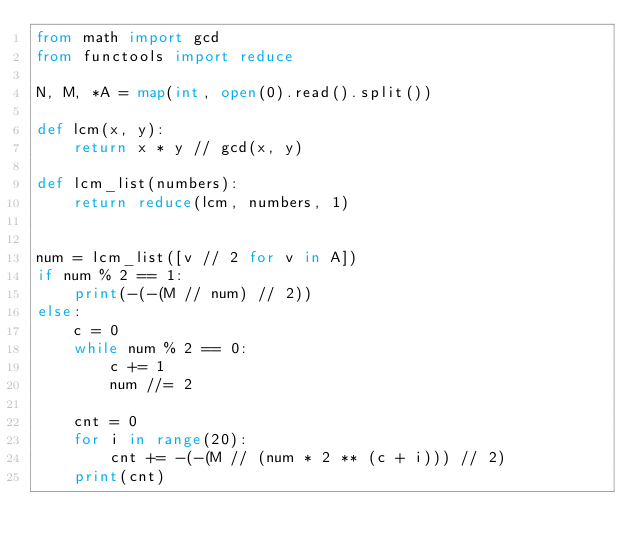<code> <loc_0><loc_0><loc_500><loc_500><_Python_>from math import gcd
from functools import reduce

N, M, *A = map(int, open(0).read().split())

def lcm(x, y):
    return x * y // gcd(x, y)

def lcm_list(numbers):
    return reduce(lcm, numbers, 1)


num = lcm_list([v // 2 for v in A])
if num % 2 == 1:
    print(-(-(M // num) // 2))
else:
    c = 0
    while num % 2 == 0:
        c += 1
        num //= 2

    cnt = 0
    for i in range(20):
        cnt += -(-(M // (num * 2 ** (c + i))) // 2)
    print(cnt)

</code> 